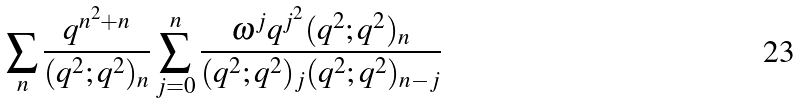<formula> <loc_0><loc_0><loc_500><loc_500>\sum _ { n } \frac { q ^ { n ^ { 2 } + n } } { ( q ^ { 2 } ; q ^ { 2 } ) _ { n } } \sum ^ { n } _ { j = 0 } \frac { { \omega } ^ { j } q ^ { j ^ { 2 } } ( q ^ { 2 } ; q ^ { 2 } ) _ { n } } { ( q ^ { 2 } ; q ^ { 2 } ) _ { j } ( q ^ { 2 } ; q ^ { 2 } ) _ { n - j } }</formula> 